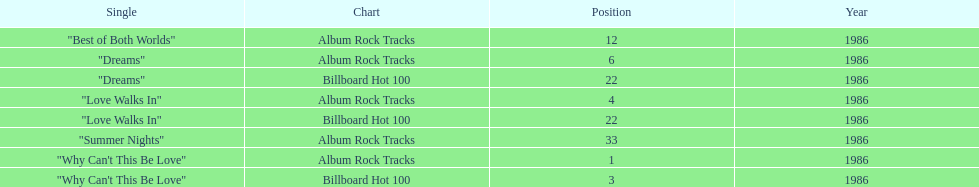Which is the most popular single on the album? Why Can't This Be Love. 